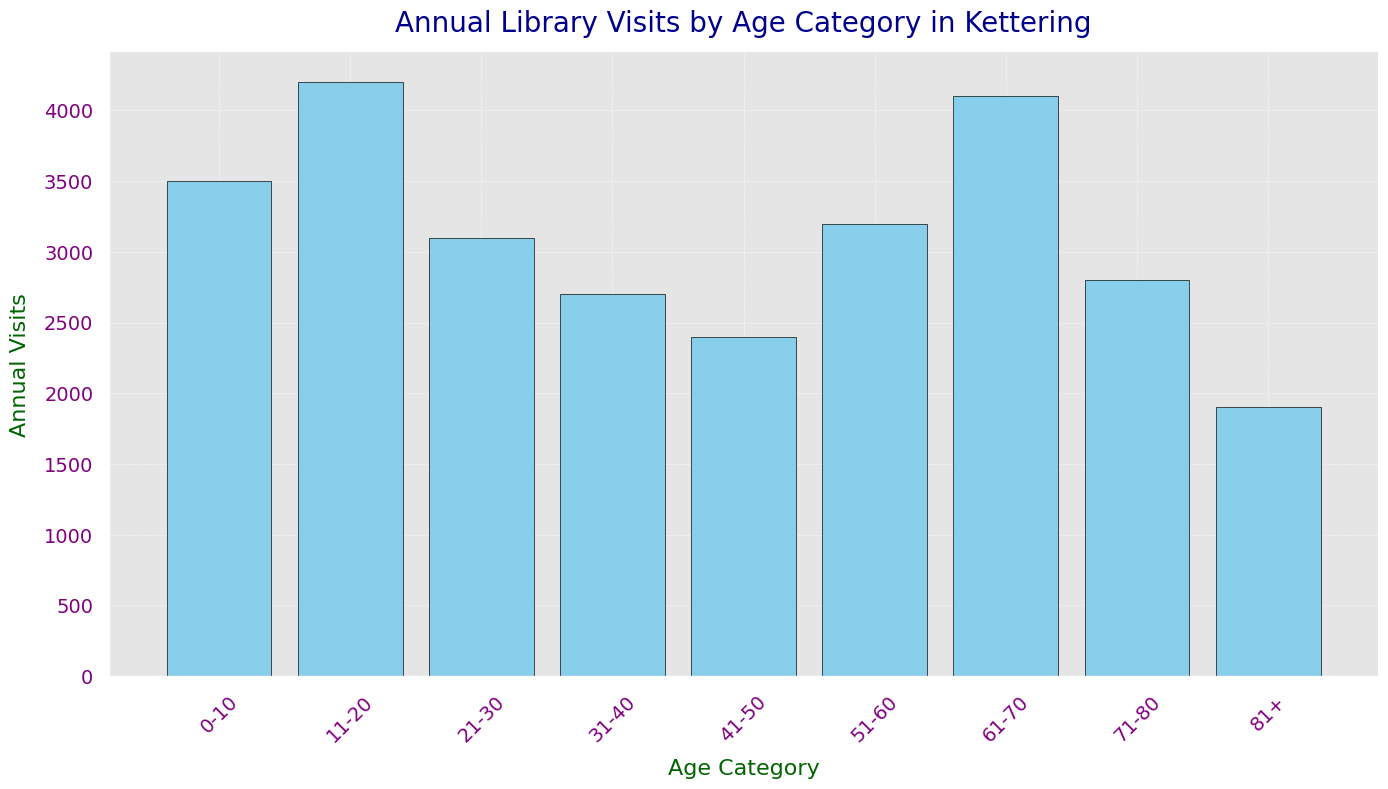What age category has the highest annual library visits? The bar representing the 11-20 age category is the tallest, indicating the highest number of annual visits at 4200.
Answer: 11-20 What is the difference in annual visits between the 21-30 and 61-70 age categories? The 61-70 age category has 4100 visits, and the 21-30 age category has 3100 visits. The difference is 4100 - 3100 = 1000.
Answer: 1000 Which two age categories have the closest number of annual library visits? By comparing the bar heights, the 31-40 category (2700) and the 71-80 category (2800) are closest in value. The difference is 2800 - 2700 = 100.
Answer: 31-40 and 71-80 What is the total annual library visits for age categories 0-10 and 81+? Summing the visits for 0-10 (3500) and 81+ (1900) gives 3500 + 1900 = 5400.
Answer: 5400 What is the average number of annual library visits across all age categories? Adding all visits together: 3500 + 4200 + 3100 + 2700 + 2400 + 3200 + 4100 + 2800 + 1900 = 27900, then dividing by the number of age categories (9) gives 27900 / 9 = 3100.
Answer: 3100 Which age category has fewer annual visits: 41-50 or 71-80? By comparing the bar heights, the 41-50 category (2400) has fewer visits than the 71-80 category (2800).
Answer: 41-50 What is the combined annual library visits of the top three most frequent age categories? The most frequent categories are 11-20 (4200), 61-70 (4100), and 0-10 (3500). Summing them gives 4200 + 4100 + 3500 = 11800.
Answer: 11800 What percentage of the total visits does the 0-10 age category contribute? Total visits are 27900, and 0-10 has 3500. The percentage is (3500 / 27900) * 100 ≈ 12.54%.
Answer: 12.54% What are the age categories with annual visits above 3000? The bars that exceed 3000 visits represent the age categories 0-10 (3500), 11-20 (4200), 21-30 (3100), and 61-70 (4100).
Answer: 0-10, 11-20, 21-30, 61-70 